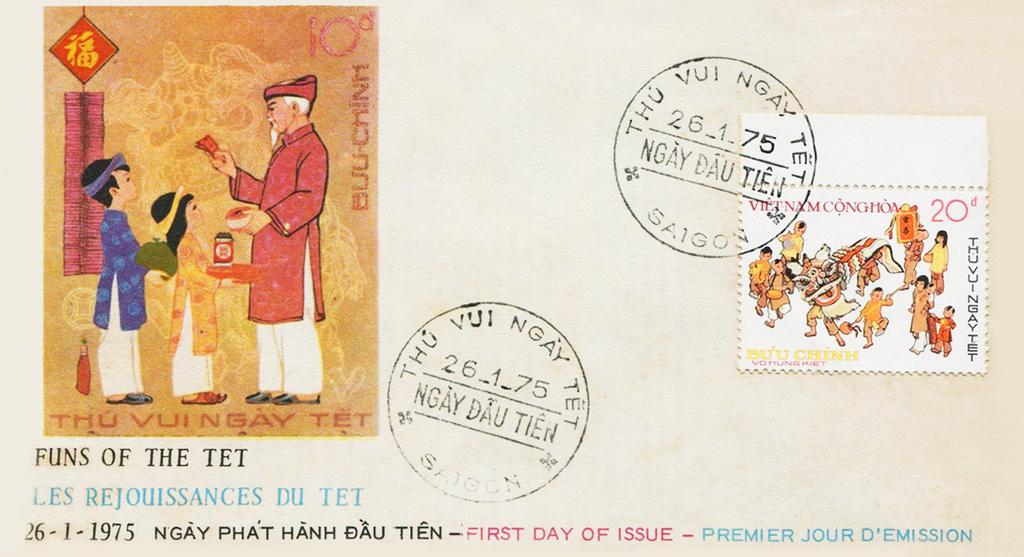What five numbers appear in the two stamped images?
Your answer should be compact. 26175. What date was the stamp issued?
Make the answer very short. 26-1-1975. 